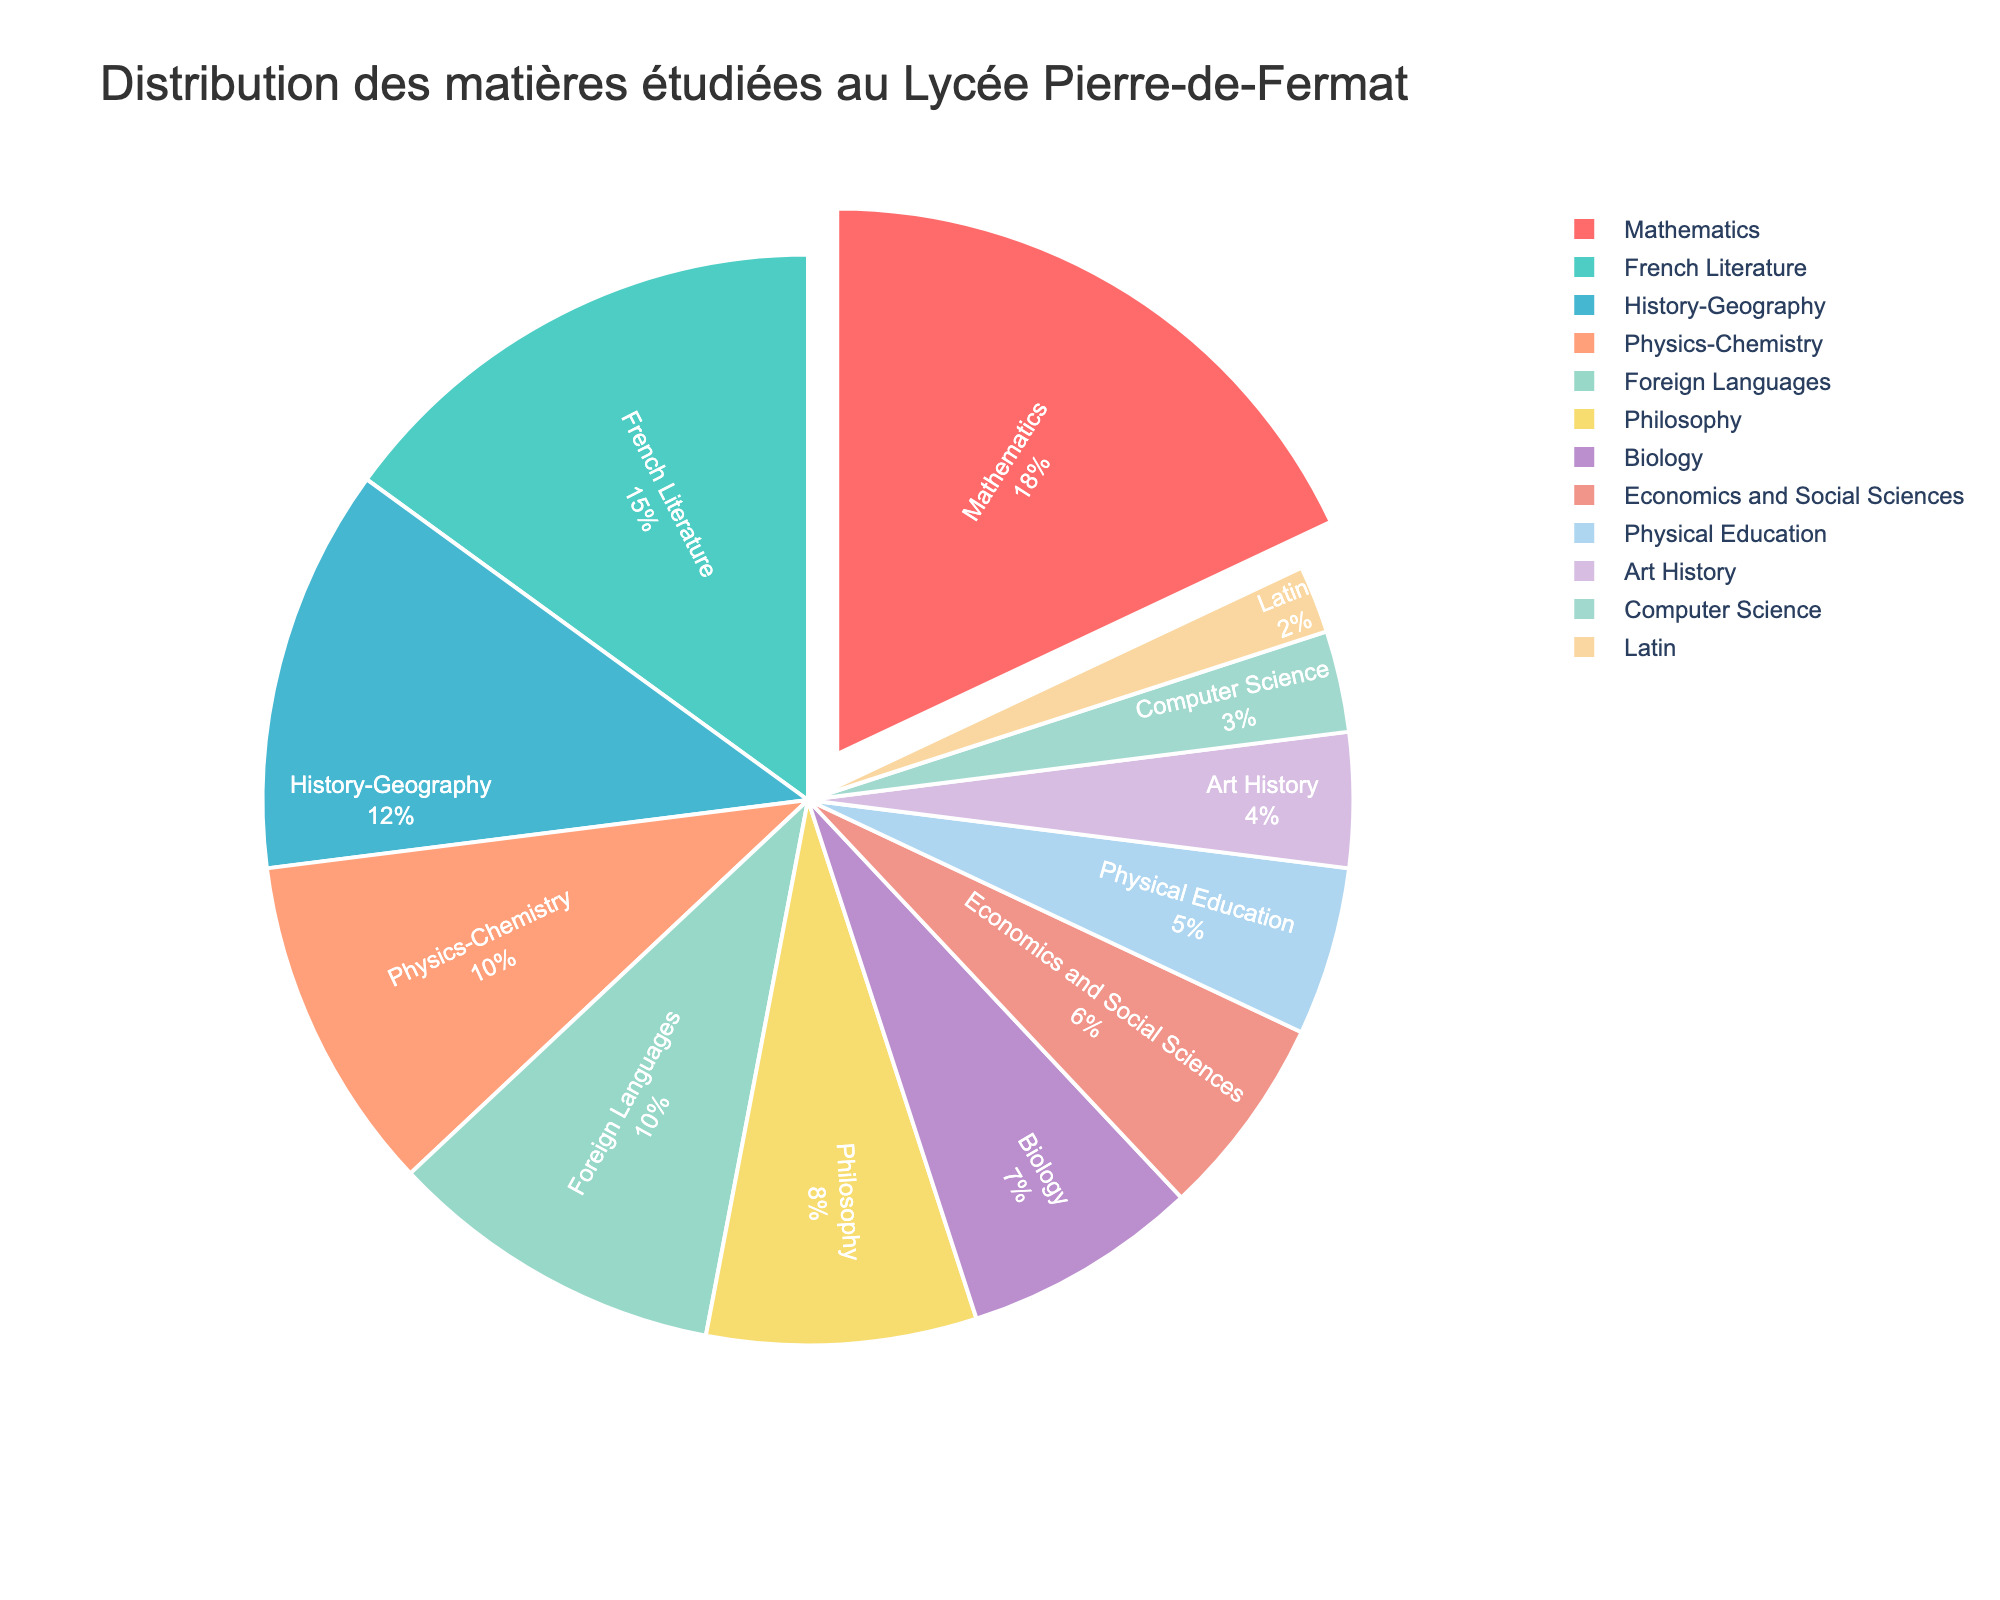What subject has the highest percentage? To determine the subject with the highest percentage, look at the sections of the pie chart and find the one with the largest segment. It is colored in red and labeled as "Mathematics" with 18%.
Answer: Mathematics How much larger is the percentage of Mathematics compared to Art History? Find the percentage values of both Mathematics (18%) and Art History (4%). Calculate the difference: 18% - 4% = 14%.
Answer: 14% What is the combined percentage of Philosophy and Latin? Locate the segments for Philosophy (8%) and Latin (2%). Add these percentages together: 8% + 2% = 10%.
Answer: 10% Which subjects have the same percentage value and what is it? Identify subjects with identical segment sizes. Physics-Chemistry (10%) and Foreign Languages (10%) have equal percentages.
Answer: Physics-Chemistry and Foreign Languages at 10% Which subject is represented by the light blue section? By examining the color legend, the light blue section corresponds to Computer Science, which has a percentage of 3%.
Answer: Computer Science How does the percentage of History-Geography compare to that of Biology? Examine the segments for History-Geography (12%) and Biology (7%). History-Geography is larger by 5% (12% - 7% = 5%).
Answer: History-Geography is 5% more What is the difference between the sum of Mathematics, French Literature, and History-Geography and the sum of Biology, Economics and Social Sciences, and Art History? Add the percentages of the first group: 18% (Mathematics) + 15% (French Literature) + 12% (History-Geography) = 45%. Add the percentages of the second group: 7% (Biology) + 6% (Economics and Social Sciences) + 4% (Art History) = 17%. Calculate the difference: 45% - 17% = 28%.
Answer: 28% If you add the percentage of Music to the chart and have a total of 100%, what would Music's percentage be? First, sum all current percentages: 18 + 15 + 12 + 10 + 10 + 8 + 7 + 6 + 5 + 4 + 3 + 2 = 100%. Since adding Music should keep the total at 100%, the percentage for Music is 0%.
Answer: 0% How many subjects have a percentage less than or equal to 5%? Examine the pie chart and count the segments with 5% or less. These include: Physical Education (5%), Art History (4%), Computer Science (3%), and Latin (2%). This totals 4 subjects.
Answer: 4 subjects 